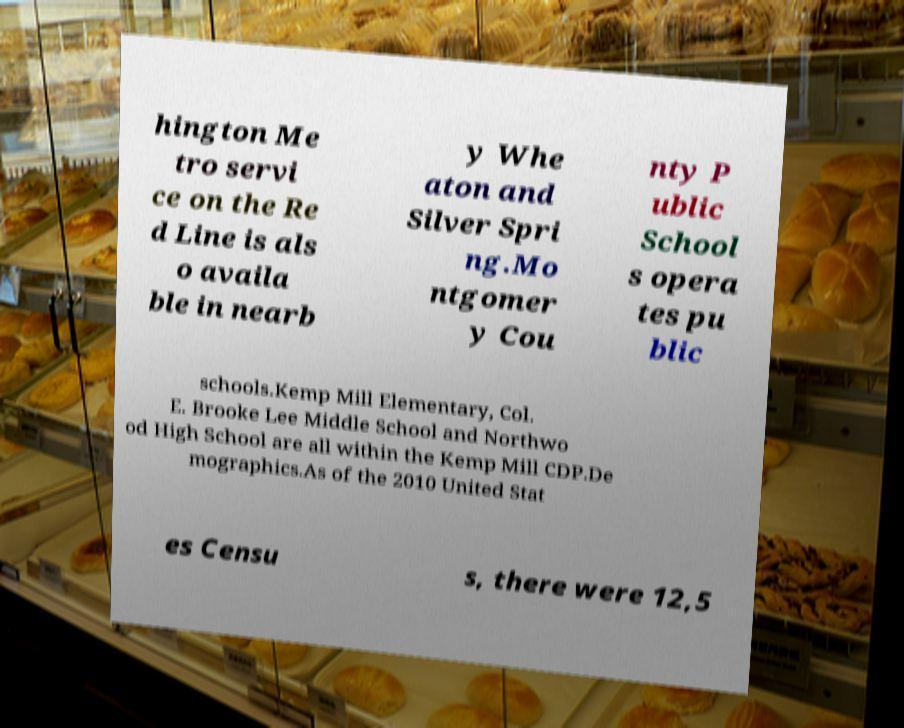Please read and relay the text visible in this image. What does it say? hington Me tro servi ce on the Re d Line is als o availa ble in nearb y Whe aton and Silver Spri ng.Mo ntgomer y Cou nty P ublic School s opera tes pu blic schools.Kemp Mill Elementary, Col. E. Brooke Lee Middle School and Northwo od High School are all within the Kemp Mill CDP.De mographics.As of the 2010 United Stat es Censu s, there were 12,5 